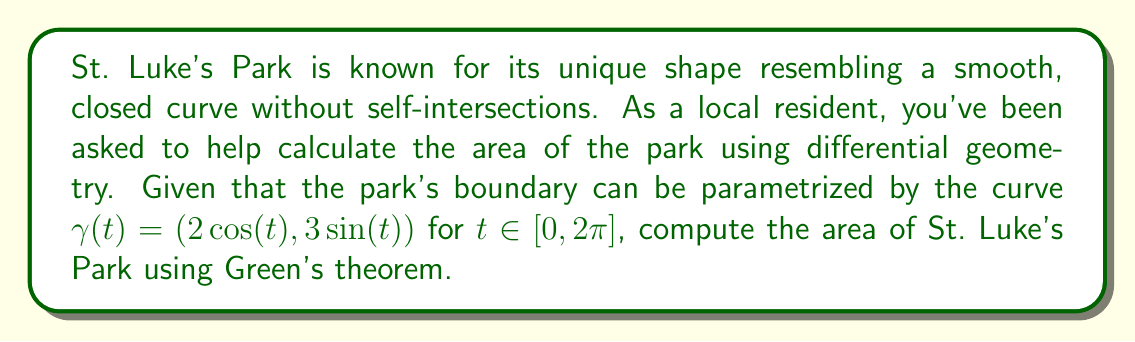Solve this math problem. To solve this problem, we'll use Green's theorem, which relates a line integral around a simple closed curve to a double integral over the plane region bounded by the curve. The steps are as follows:

1) Green's theorem states that for a region D bounded by a simple closed curve C:

   $$\oint_C (P dx + Q dy) = \iint_D \left(\frac{\partial Q}{\partial x} - \frac{\partial P}{\partial y}\right) dA$$

2) To find the area, we can choose $P = -y/2$ and $Q = x/2$. This gives:

   $$\frac{\partial Q}{\partial x} - \frac{\partial P}{\partial y} = \frac{1}{2} - \frac{1}{2} = 1$$

3) Thus, the area is given by:

   $$\text{Area} = \frac{1}{2}\oint_C (x dy - y dx)$$

4) We parametrize the curve as given: $x = 2\cos(t)$, $y = 3\sin(t)$, $t \in [0, 2\pi]$

5) We need to calculate:
   $dx = -2\sin(t)dt$
   $dy = 3\cos(t)dt$

6) Substituting into the integral:

   $$\text{Area} = \frac{1}{2}\int_0^{2\pi} (2\cos(t) \cdot 3\cos(t) - 3\sin(t) \cdot (-2\sin(t))) dt$$

7) Simplifying:

   $$\text{Area} = \frac{1}{2}\int_0^{2\pi} (6\cos^2(t) + 6\sin^2(t)) dt$$
   $$= 3\int_0^{2\pi} (\cos^2(t) + \sin^2(t)) dt$$
   $$= 3\int_0^{2\pi} 1 dt$$

8) Evaluating the integral:

   $$\text{Area} = 3 \cdot 2\pi = 6\pi$$

Therefore, the area of St. Luke's Park is $6\pi$ square units.
Answer: $6\pi$ square units 